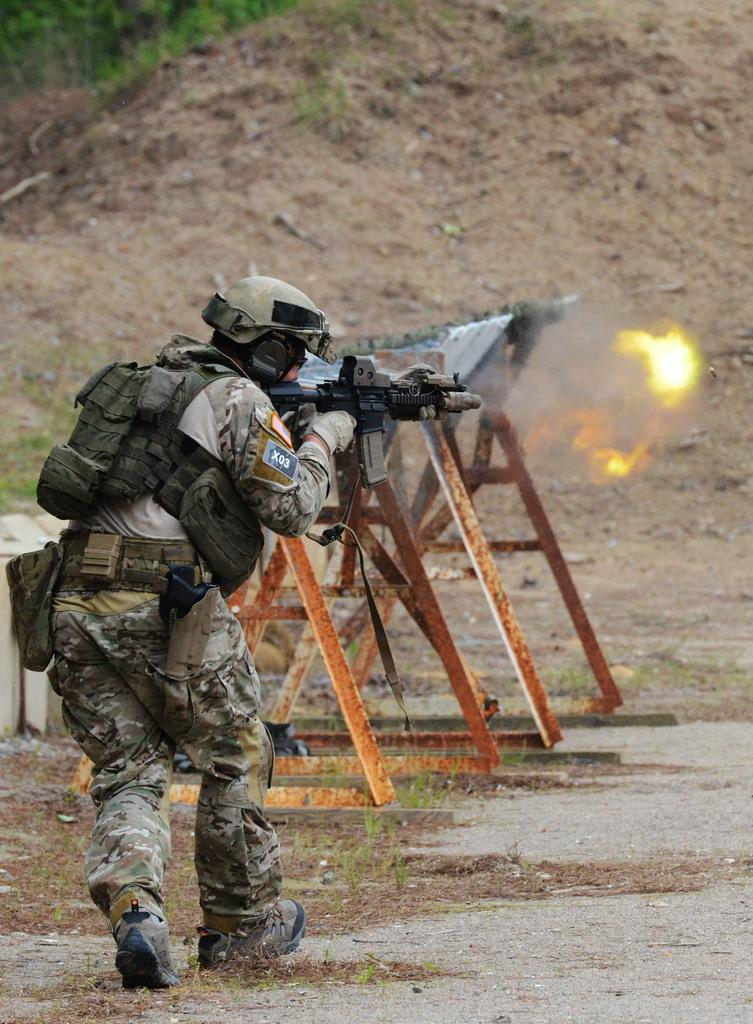What is there is a person in the image, what are they doing? There is a person running in the image. What is the person holding while running? The person is holding a gun. What can be seen in the background of the image? There is equipment visible in the background, and grass is present as well. What type of surface is visible in the image? There is ground visible in the image. What type of tools does the duck use while serving the carpenter in the image? There is no duck or carpenter present in the image, and therefore no such interaction can be observed. 